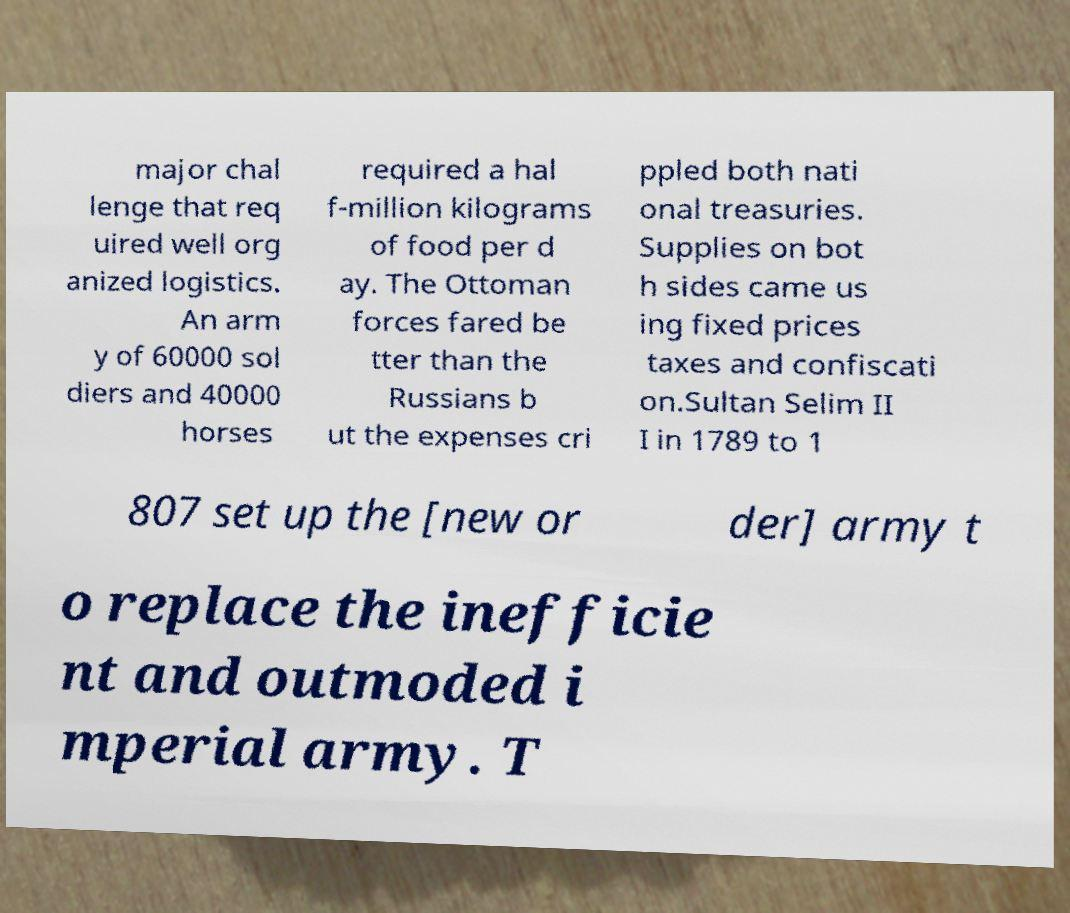Can you accurately transcribe the text from the provided image for me? major chal lenge that req uired well org anized logistics. An arm y of 60000 sol diers and 40000 horses required a hal f-million kilograms of food per d ay. The Ottoman forces fared be tter than the Russians b ut the expenses cri ppled both nati onal treasuries. Supplies on bot h sides came us ing fixed prices taxes and confiscati on.Sultan Selim II I in 1789 to 1 807 set up the [new or der] army t o replace the inefficie nt and outmoded i mperial army. T 